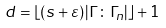<formula> <loc_0><loc_0><loc_500><loc_500>d = \left \lfloor ( s + \varepsilon ) \left | \Gamma \colon \Gamma _ { n } \right | \right \rfloor + 1</formula> 